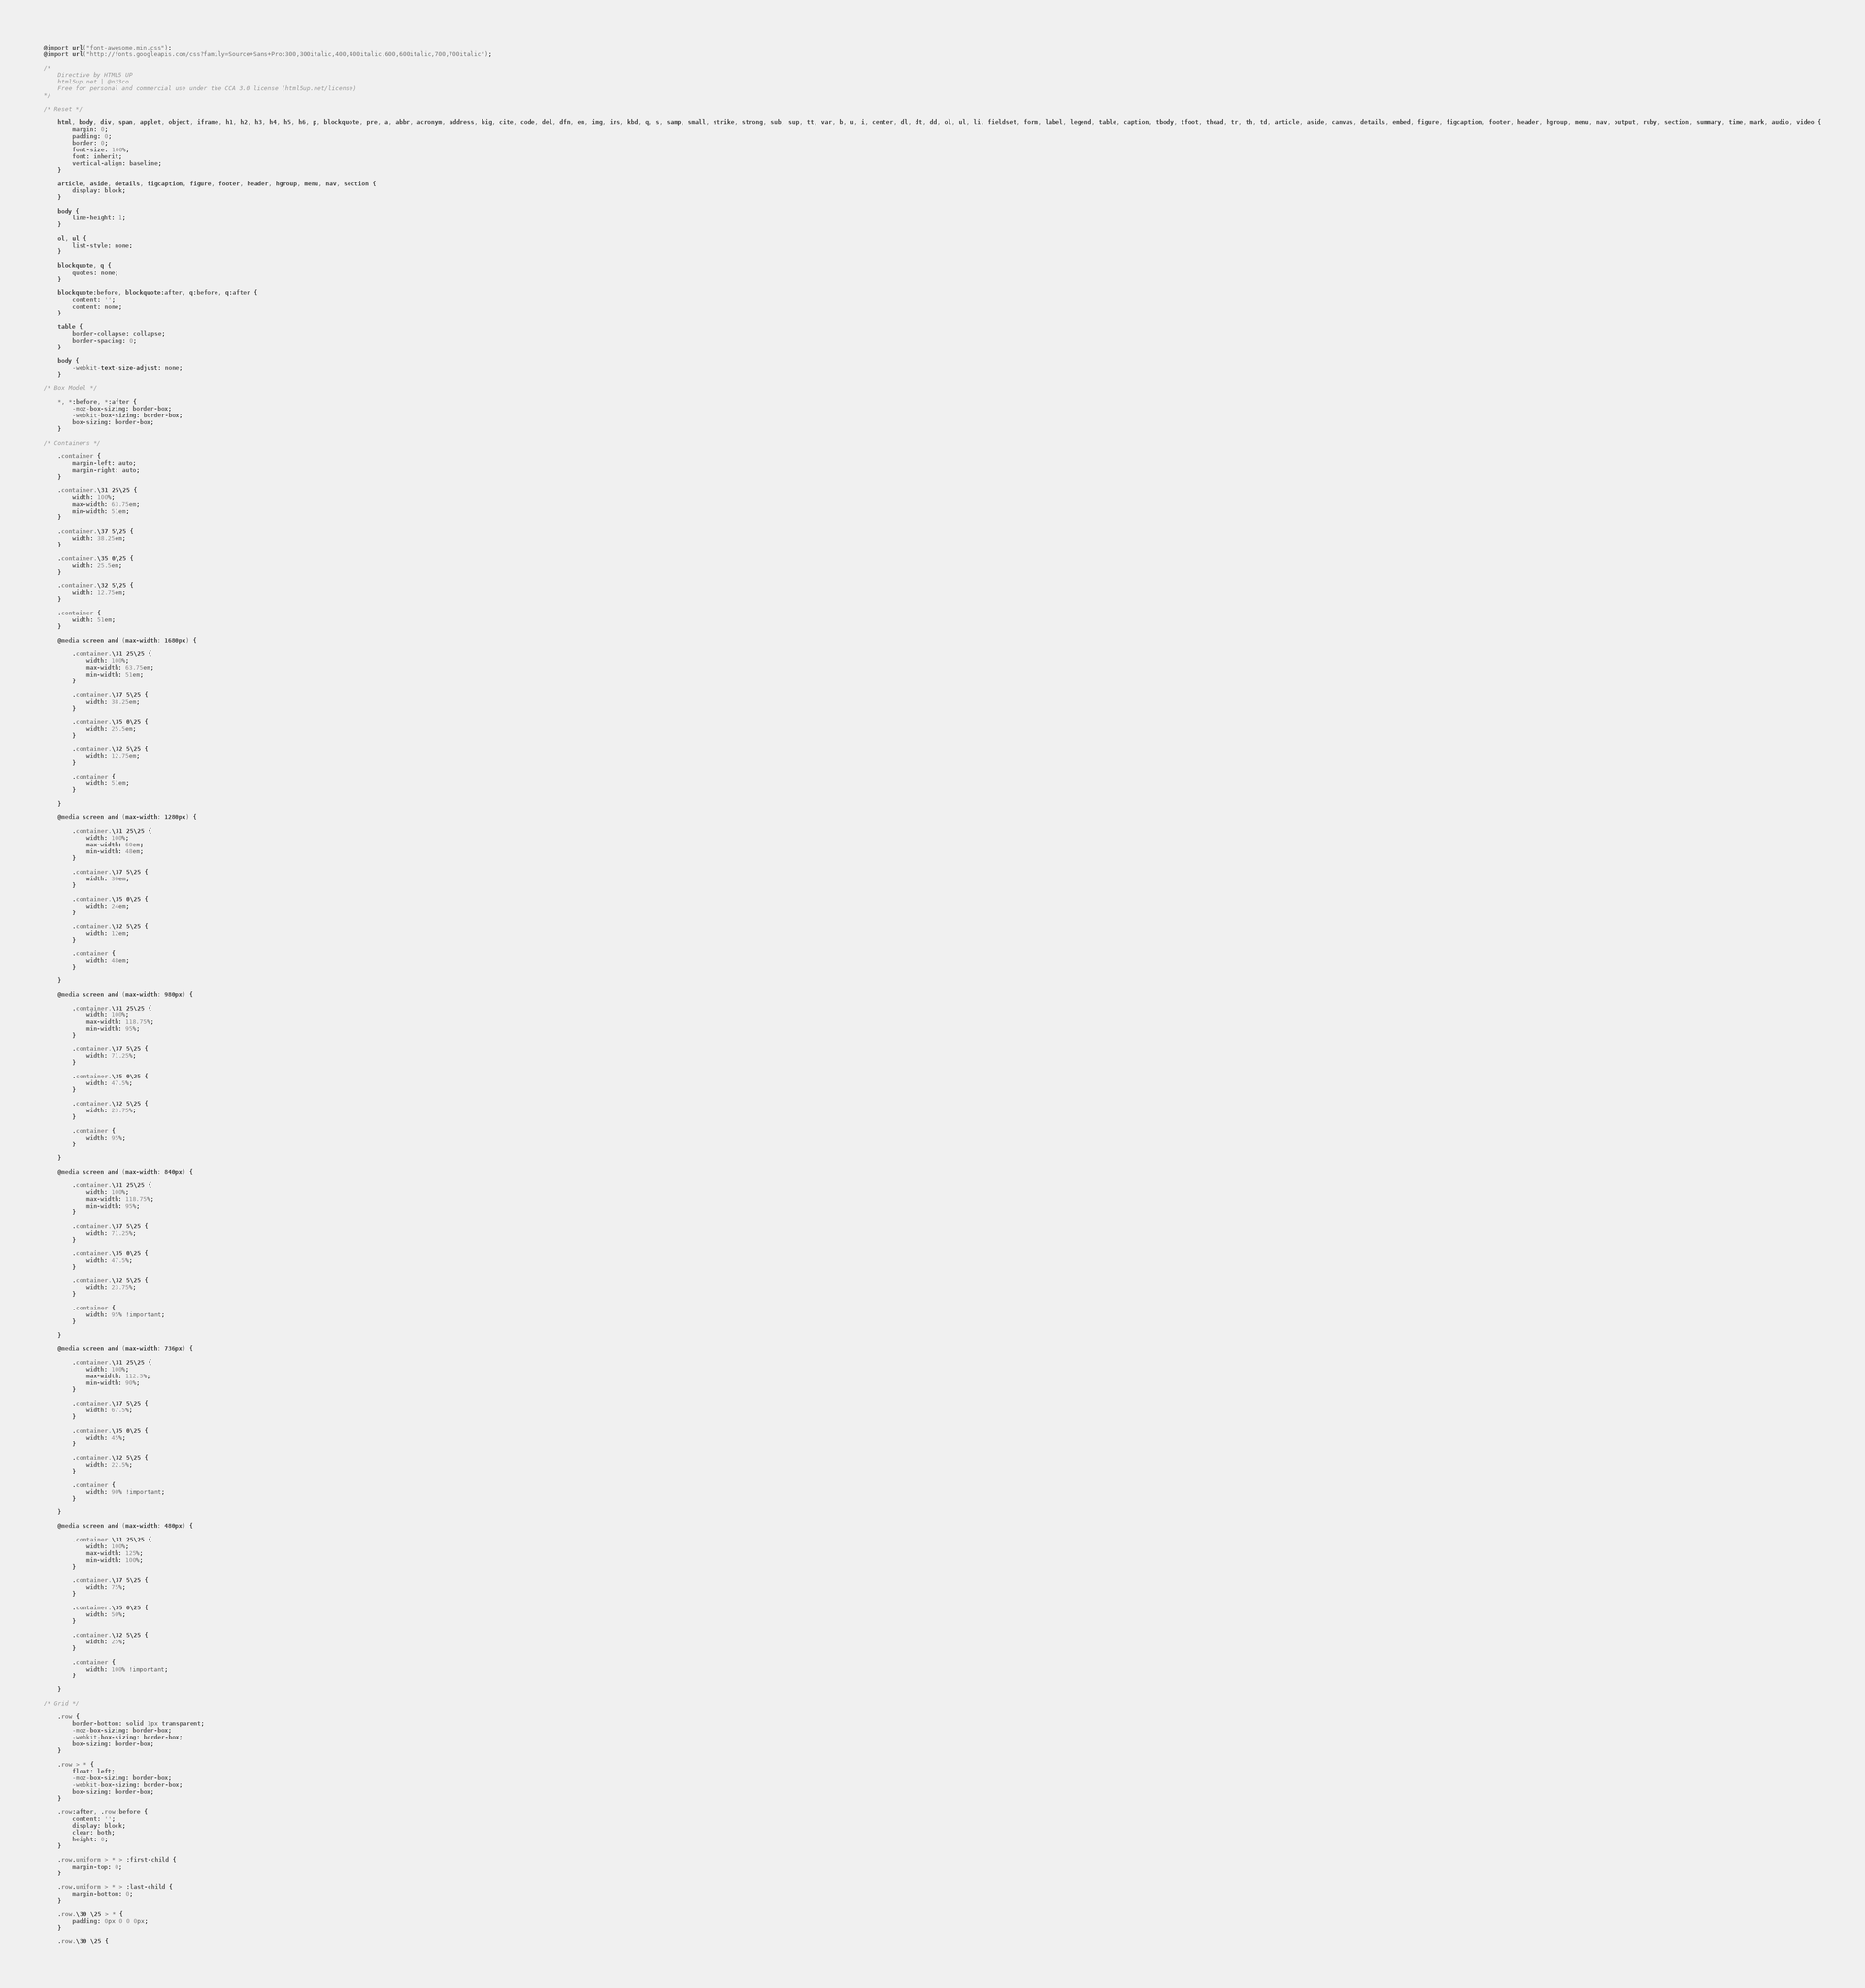<code> <loc_0><loc_0><loc_500><loc_500><_CSS_>@import url("font-awesome.min.css");
@import url("http://fonts.googleapis.com/css?family=Source+Sans+Pro:300,300italic,400,400italic,600,600italic,700,700italic");

/*
	Directive by HTML5 UP
	html5up.net | @n33co
	Free for personal and commercial use under the CCA 3.0 license (html5up.net/license)
*/

/* Reset */

	html, body, div, span, applet, object, iframe, h1, h2, h3, h4, h5, h6, p, blockquote, pre, a, abbr, acronym, address, big, cite, code, del, dfn, em, img, ins, kbd, q, s, samp, small, strike, strong, sub, sup, tt, var, b, u, i, center, dl, dt, dd, ol, ul, li, fieldset, form, label, legend, table, caption, tbody, tfoot, thead, tr, th, td, article, aside, canvas, details, embed, figure, figcaption, footer, header, hgroup, menu, nav, output, ruby, section, summary, time, mark, audio, video {
		margin: 0;
		padding: 0;
		border: 0;
		font-size: 100%;
		font: inherit;
		vertical-align: baseline;
	}

	article, aside, details, figcaption, figure, footer, header, hgroup, menu, nav, section {
		display: block;
	}

	body {
		line-height: 1;
	}

	ol, ul {
		list-style: none;
	}

	blockquote, q {
		quotes: none;
	}

	blockquote:before, blockquote:after, q:before, q:after {
		content: '';
		content: none;
	}

	table {
		border-collapse: collapse;
		border-spacing: 0;
	}

	body {
		-webkit-text-size-adjust: none;
	}

/* Box Model */

	*, *:before, *:after {
		-moz-box-sizing: border-box;
		-webkit-box-sizing: border-box;
		box-sizing: border-box;
	}

/* Containers */

	.container {
		margin-left: auto;
		margin-right: auto;
	}

	.container.\31 25\25 {
		width: 100%;
		max-width: 63.75em;
		min-width: 51em;
	}

	.container.\37 5\25 {
		width: 38.25em;
	}

	.container.\35 0\25 {
		width: 25.5em;
	}

	.container.\32 5\25 {
		width: 12.75em;
	}

	.container {
		width: 51em;
	}

	@media screen and (max-width: 1680px) {

		.container.\31 25\25 {
			width: 100%;
			max-width: 63.75em;
			min-width: 51em;
		}

		.container.\37 5\25 {
			width: 38.25em;
		}

		.container.\35 0\25 {
			width: 25.5em;
		}

		.container.\32 5\25 {
			width: 12.75em;
		}

		.container {
			width: 51em;
		}

	}

	@media screen and (max-width: 1280px) {

		.container.\31 25\25 {
			width: 100%;
			max-width: 60em;
			min-width: 48em;
		}

		.container.\37 5\25 {
			width: 36em;
		}

		.container.\35 0\25 {
			width: 24em;
		}

		.container.\32 5\25 {
			width: 12em;
		}

		.container {
			width: 48em;
		}

	}

	@media screen and (max-width: 980px) {

		.container.\31 25\25 {
			width: 100%;
			max-width: 118.75%;
			min-width: 95%;
		}

		.container.\37 5\25 {
			width: 71.25%;
		}

		.container.\35 0\25 {
			width: 47.5%;
		}

		.container.\32 5\25 {
			width: 23.75%;
		}

		.container {
			width: 95%;
		}

	}

	@media screen and (max-width: 840px) {

		.container.\31 25\25 {
			width: 100%;
			max-width: 118.75%;
			min-width: 95%;
		}

		.container.\37 5\25 {
			width: 71.25%;
		}

		.container.\35 0\25 {
			width: 47.5%;
		}

		.container.\32 5\25 {
			width: 23.75%;
		}

		.container {
			width: 95% !important;
		}

	}

	@media screen and (max-width: 736px) {

		.container.\31 25\25 {
			width: 100%;
			max-width: 112.5%;
			min-width: 90%;
		}

		.container.\37 5\25 {
			width: 67.5%;
		}

		.container.\35 0\25 {
			width: 45%;
		}

		.container.\32 5\25 {
			width: 22.5%;
		}

		.container {
			width: 90% !important;
		}

	}

	@media screen and (max-width: 480px) {

		.container.\31 25\25 {
			width: 100%;
			max-width: 125%;
			min-width: 100%;
		}

		.container.\37 5\25 {
			width: 75%;
		}

		.container.\35 0\25 {
			width: 50%;
		}

		.container.\32 5\25 {
			width: 25%;
		}

		.container {
			width: 100% !important;
		}

	}

/* Grid */

	.row {
		border-bottom: solid 1px transparent;
		-moz-box-sizing: border-box;
		-webkit-box-sizing: border-box;
		box-sizing: border-box;
	}

	.row > * {
		float: left;
		-moz-box-sizing: border-box;
		-webkit-box-sizing: border-box;
		box-sizing: border-box;
	}

	.row:after, .row:before {
		content: '';
		display: block;
		clear: both;
		height: 0;
	}

	.row.uniform > * > :first-child {
		margin-top: 0;
	}

	.row.uniform > * > :last-child {
		margin-bottom: 0;
	}

	.row.\30 \25 > * {
		padding: 0px 0 0 0px;
	}

	.row.\30 \25 {</code> 